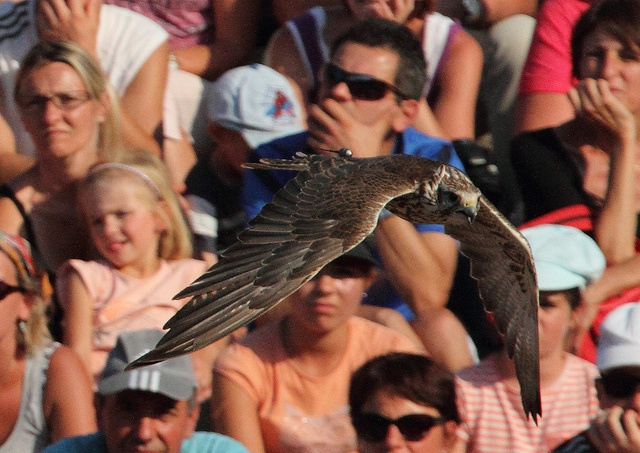Describe the objects in this image and their specific colors. I can see bird in salmon, black, gray, and maroon tones, people in salmon, black, gray, brown, and maroon tones, people in salmon, black, brown, and maroon tones, people in salmon, black, tan, and maroon tones, and people in salmon, maroon, and brown tones in this image. 